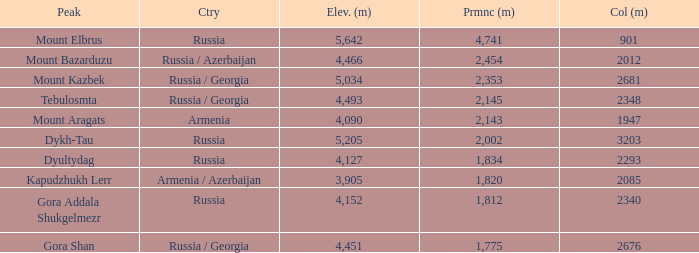What is the Col (m) of Peak Mount Aragats with an Elevation (m) larger than 3,905 and Prominence smaller than 2,143? None. 